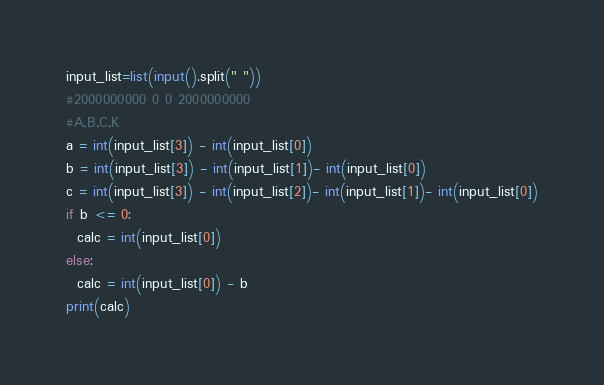<code> <loc_0><loc_0><loc_500><loc_500><_Python_>input_list=list(input().split(" "))
#2000000000 0 0 2000000000
#A,B,C,K
a = int(input_list[3]) - int(input_list[0])
b = int(input_list[3]) - int(input_list[1])- int(input_list[0])
c = int(input_list[3]) - int(input_list[2])- int(input_list[1])- int(input_list[0])
if b <= 0:
  calc = int(input_list[0])
else:
  calc = int(input_list[0]) - b
print(calc)</code> 